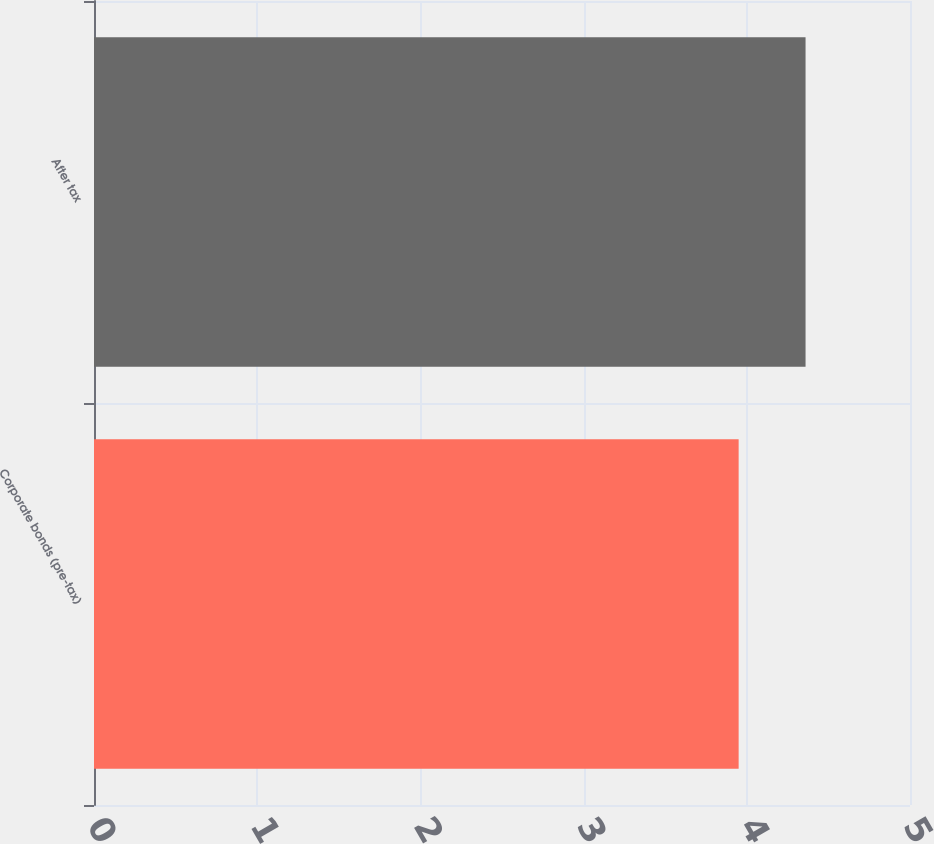<chart> <loc_0><loc_0><loc_500><loc_500><bar_chart><fcel>Corporate bonds (pre-tax)<fcel>After tax<nl><fcel>3.95<fcel>4.36<nl></chart> 